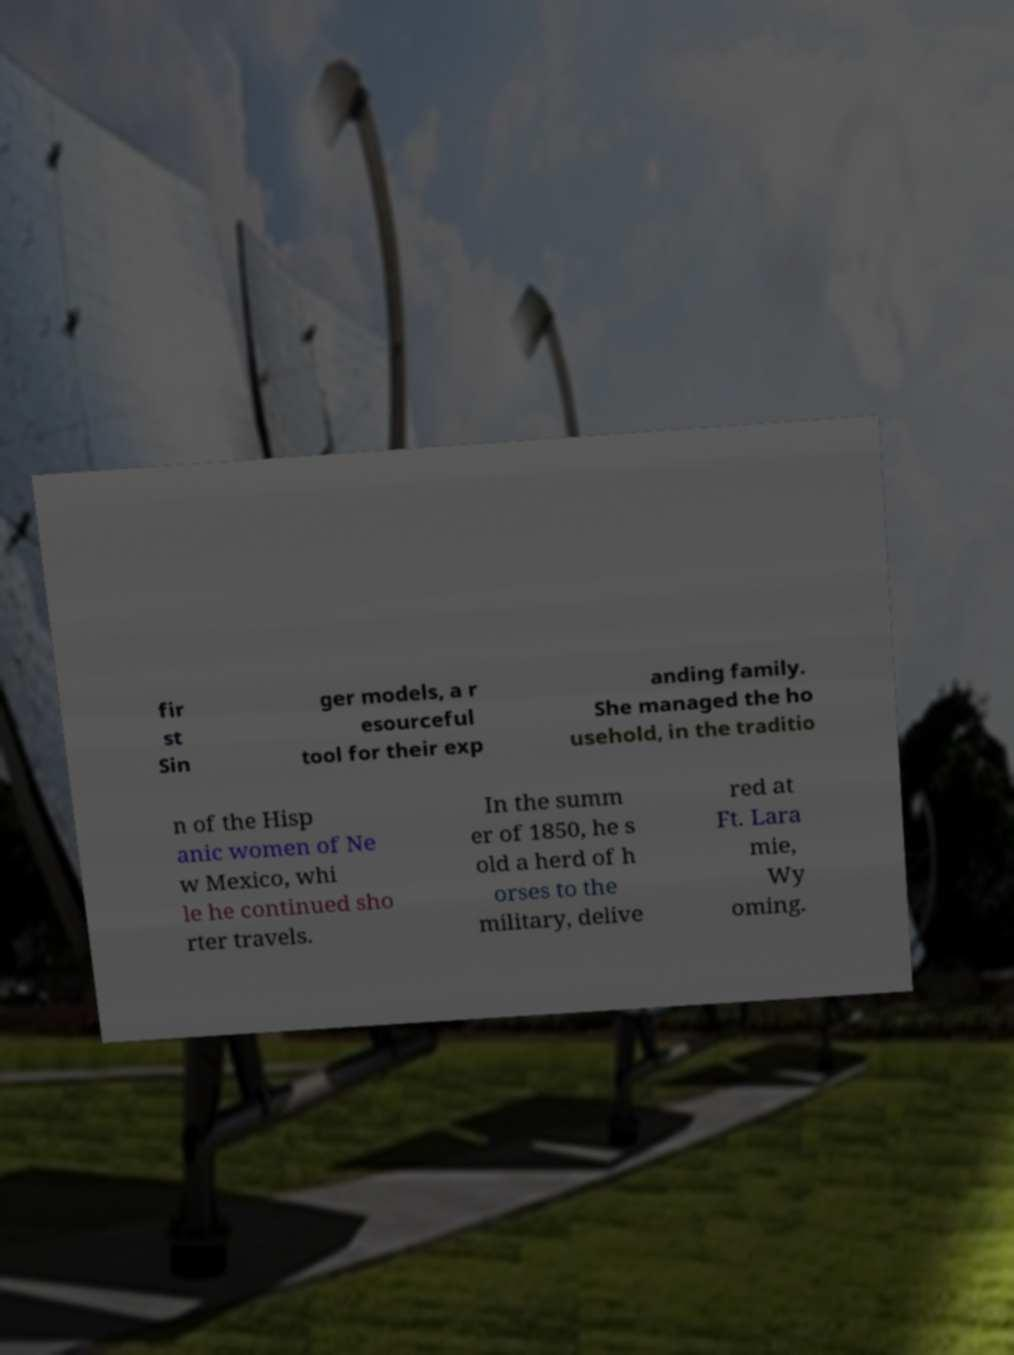Please identify and transcribe the text found in this image. fir st Sin ger models, a r esourceful tool for their exp anding family. She managed the ho usehold, in the traditio n of the Hisp anic women of Ne w Mexico, whi le he continued sho rter travels. In the summ er of 1850, he s old a herd of h orses to the military, delive red at Ft. Lara mie, Wy oming. 